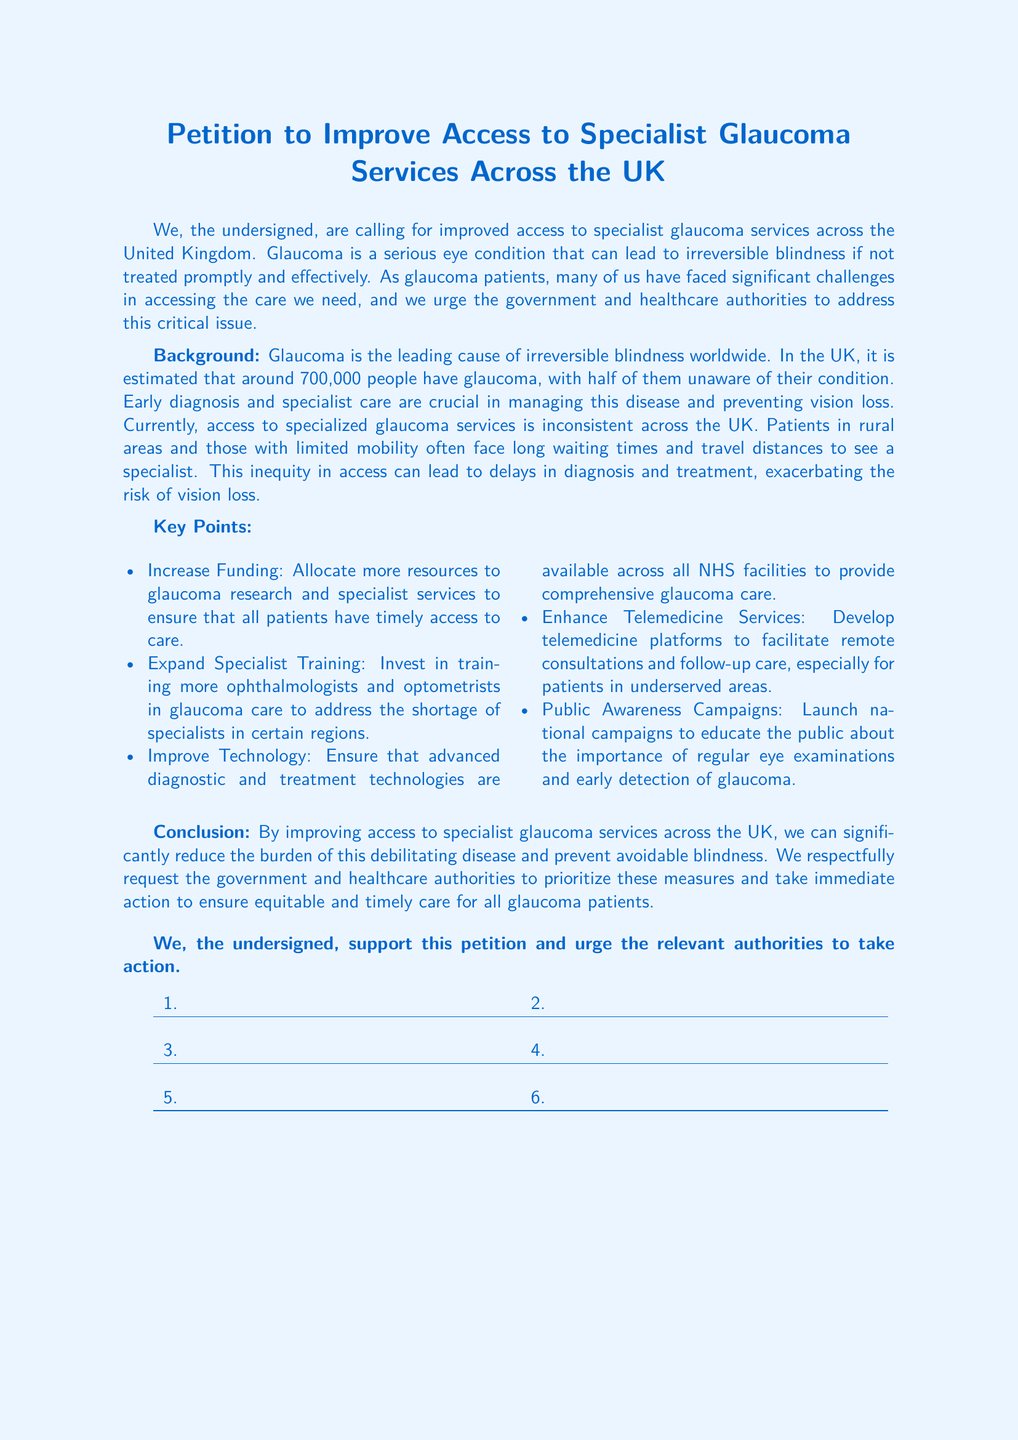what is the title of the document? The title is a central feature of the document and states its purpose clearly.
Answer: Petition to Improve Access to Specialist Glaucoma Services Across the UK how many people in the UK are estimated to have glaucoma? The document provides an estimate which is a key statistic that highlights the prevalence of the condition.
Answer: around 700,000 what is the leading cause of irreversible blindness worldwide? This information underscores the seriousness of the disease and its global impact.
Answer: Glaucoma what is one of the key points mentioned in the petition? This question targets a specific aspect of the petition that outlines proposed actions.
Answer: Increase Funding what does the petition urge the government and healthcare authorities to prioritize? The petition's conclusion directly states its request, focusing on the main objective.
Answer: equitable and timely care which technology improvement is suggested in the petition? This question asks for specific technology-related requests mentioned in the document.
Answer: Improve Technology what type of campaigns are proposed to raise public awareness? The document emphasizes health promotion strategies to improve detection rates of glaucoma.
Answer: Public Awareness Campaigns how many points are listed in the Key Points section? This question requires counting the distinct items mentioned in that section.
Answer: five 